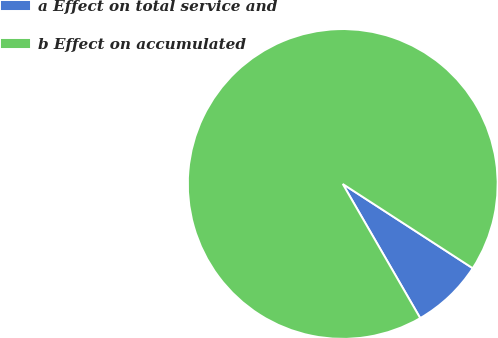<chart> <loc_0><loc_0><loc_500><loc_500><pie_chart><fcel>a Effect on total service and<fcel>b Effect on accumulated<nl><fcel>7.51%<fcel>92.49%<nl></chart> 